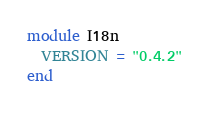<code> <loc_0><loc_0><loc_500><loc_500><_Ruby_>module I18n
  VERSION = "0.4.2"
end
</code> 